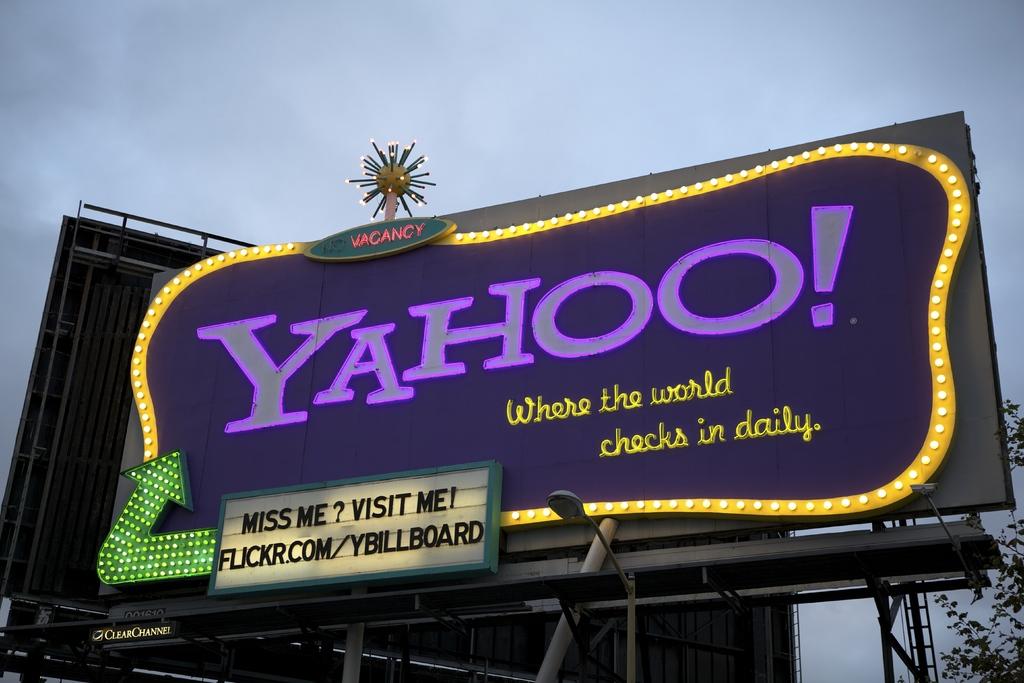What website is on the white board?
Offer a very short reply. Flickr.com/ybillboard. What's the quote below the yahoo logo?
Ensure brevity in your answer.  Where the world checks in daily. 